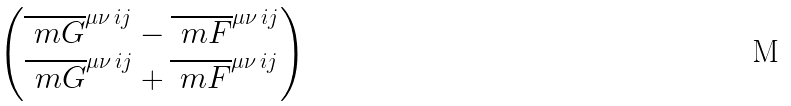Convert formula to latex. <formula><loc_0><loc_0><loc_500><loc_500>\begin{pmatrix} \overline { \ m G } ^ { \mu \nu \, i j } - \overline { \ m F } ^ { \mu \nu \, i j } \\ \overline { \ m G } ^ { \mu \nu \, i j } + \overline { \ m F } ^ { \mu \nu \, i j } \end{pmatrix}</formula> 